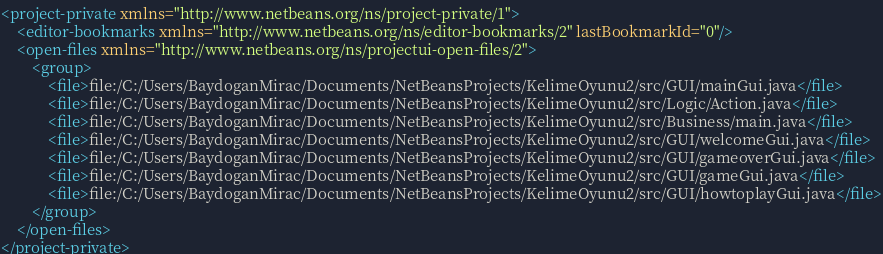<code> <loc_0><loc_0><loc_500><loc_500><_XML_><project-private xmlns="http://www.netbeans.org/ns/project-private/1">
    <editor-bookmarks xmlns="http://www.netbeans.org/ns/editor-bookmarks/2" lastBookmarkId="0"/>
    <open-files xmlns="http://www.netbeans.org/ns/projectui-open-files/2">
        <group>
            <file>file:/C:/Users/BaydoganMirac/Documents/NetBeansProjects/KelimeOyunu2/src/GUI/mainGui.java</file>
            <file>file:/C:/Users/BaydoganMirac/Documents/NetBeansProjects/KelimeOyunu2/src/Logic/Action.java</file>
            <file>file:/C:/Users/BaydoganMirac/Documents/NetBeansProjects/KelimeOyunu2/src/Business/main.java</file>
            <file>file:/C:/Users/BaydoganMirac/Documents/NetBeansProjects/KelimeOyunu2/src/GUI/welcomeGui.java</file>
            <file>file:/C:/Users/BaydoganMirac/Documents/NetBeansProjects/KelimeOyunu2/src/GUI/gameoverGui.java</file>
            <file>file:/C:/Users/BaydoganMirac/Documents/NetBeansProjects/KelimeOyunu2/src/GUI/gameGui.java</file>
            <file>file:/C:/Users/BaydoganMirac/Documents/NetBeansProjects/KelimeOyunu2/src/GUI/howtoplayGui.java</file>
        </group>
    </open-files>
</project-private>
</code> 